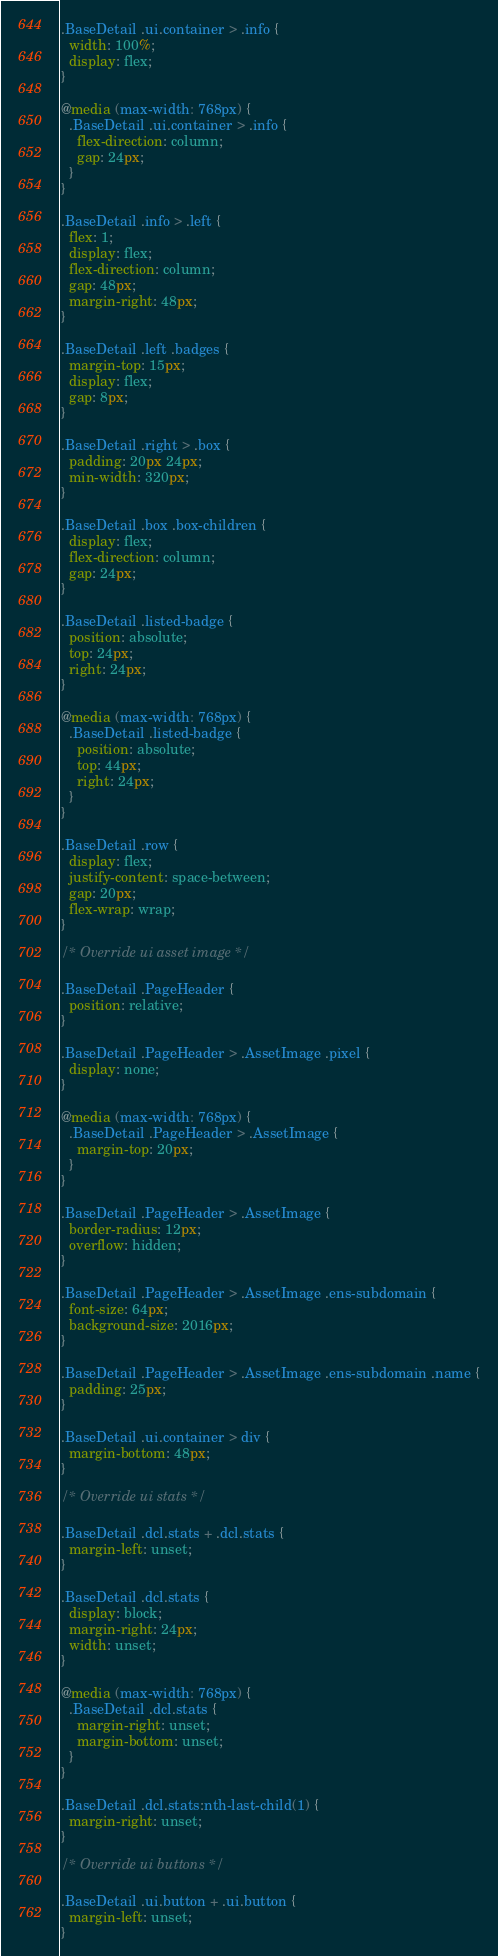<code> <loc_0><loc_0><loc_500><loc_500><_CSS_>.BaseDetail .ui.container > .info {
  width: 100%;
  display: flex;
}

@media (max-width: 768px) {
  .BaseDetail .ui.container > .info {
    flex-direction: column;
    gap: 24px;
  }
}

.BaseDetail .info > .left {
  flex: 1;
  display: flex;
  flex-direction: column;
  gap: 48px;
  margin-right: 48px;
}

.BaseDetail .left .badges {
  margin-top: 15px;
  display: flex;
  gap: 8px;
}

.BaseDetail .right > .box {
  padding: 20px 24px;
  min-width: 320px;
}

.BaseDetail .box .box-children {
  display: flex;
  flex-direction: column;
  gap: 24px;
}

.BaseDetail .listed-badge {
  position: absolute;
  top: 24px;
  right: 24px;
}

@media (max-width: 768px) {
  .BaseDetail .listed-badge {
    position: absolute;
    top: 44px;
    right: 24px;
  }
}

.BaseDetail .row {
  display: flex;
  justify-content: space-between;
  gap: 20px;
  flex-wrap: wrap;
}

/* Override ui asset image */

.BaseDetail .PageHeader {
  position: relative;
}

.BaseDetail .PageHeader > .AssetImage .pixel {
  display: none;
}

@media (max-width: 768px) {
  .BaseDetail .PageHeader > .AssetImage {
    margin-top: 20px;
  }
}

.BaseDetail .PageHeader > .AssetImage {
  border-radius: 12px;
  overflow: hidden;
}

.BaseDetail .PageHeader > .AssetImage .ens-subdomain {
  font-size: 64px;
  background-size: 2016px;
}

.BaseDetail .PageHeader > .AssetImage .ens-subdomain .name {
  padding: 25px;
}

.BaseDetail .ui.container > div {
  margin-bottom: 48px;
}

/* Override ui stats */

.BaseDetail .dcl.stats + .dcl.stats {
  margin-left: unset;
}

.BaseDetail .dcl.stats {
  display: block;
  margin-right: 24px;
  width: unset;
}

@media (max-width: 768px) {
  .BaseDetail .dcl.stats {
    margin-right: unset;
    margin-bottom: unset;
  }
}

.BaseDetail .dcl.stats:nth-last-child(1) {
  margin-right: unset;
}

/* Override ui buttons */

.BaseDetail .ui.button + .ui.button {
  margin-left: unset;
}
</code> 